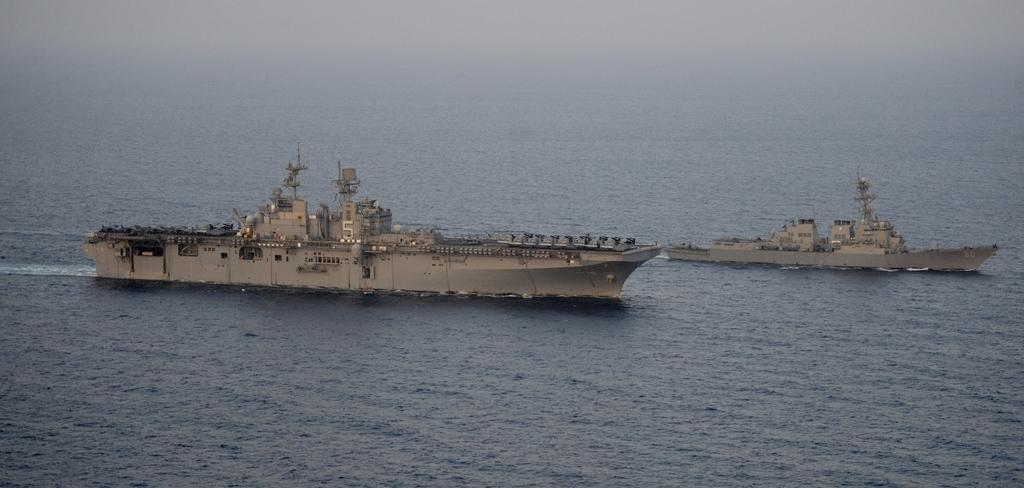What type of vehicles are in the image? There are ships in the image. Where are the ships located? The ships are on the water. What type of juice is being served on the ships in the image? There is no juice or indication of any beverage being served on the ships in the image. 